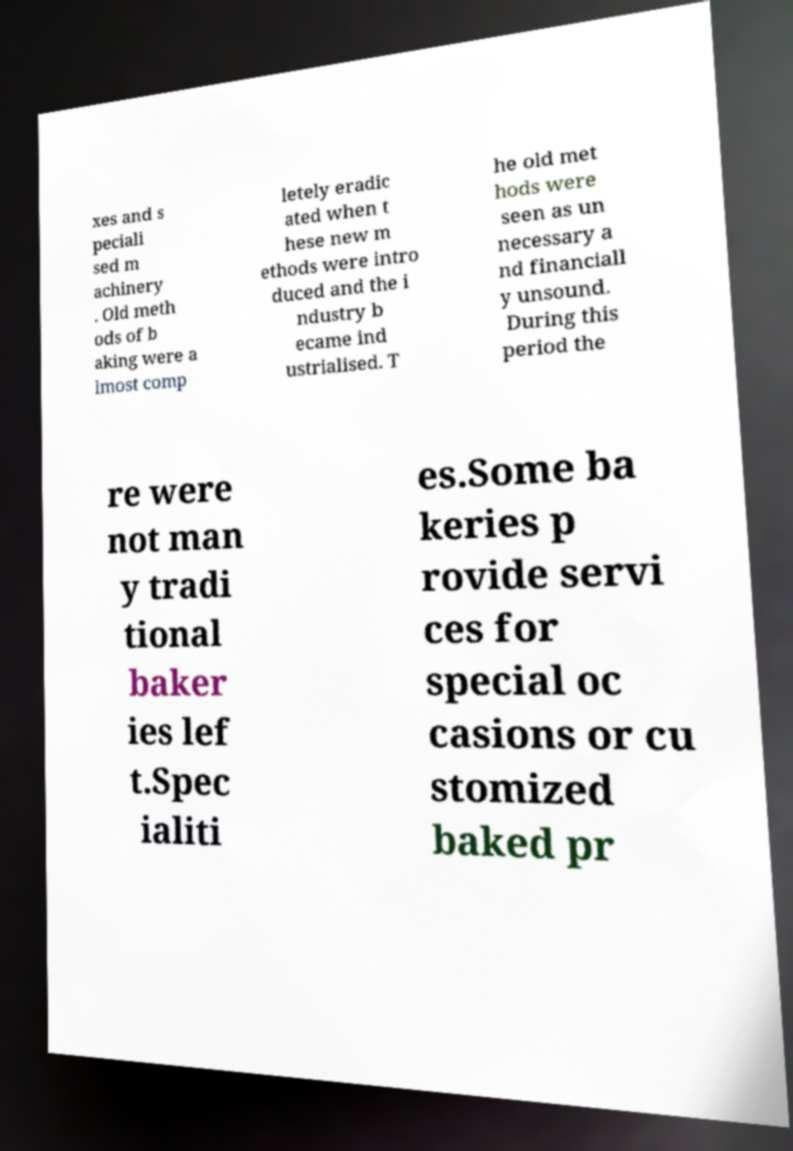Could you extract and type out the text from this image? xes and s peciali sed m achinery . Old meth ods of b aking were a lmost comp letely eradic ated when t hese new m ethods were intro duced and the i ndustry b ecame ind ustrialised. T he old met hods were seen as un necessary a nd financiall y unsound. During this period the re were not man y tradi tional baker ies lef t.Spec ialiti es.Some ba keries p rovide servi ces for special oc casions or cu stomized baked pr 